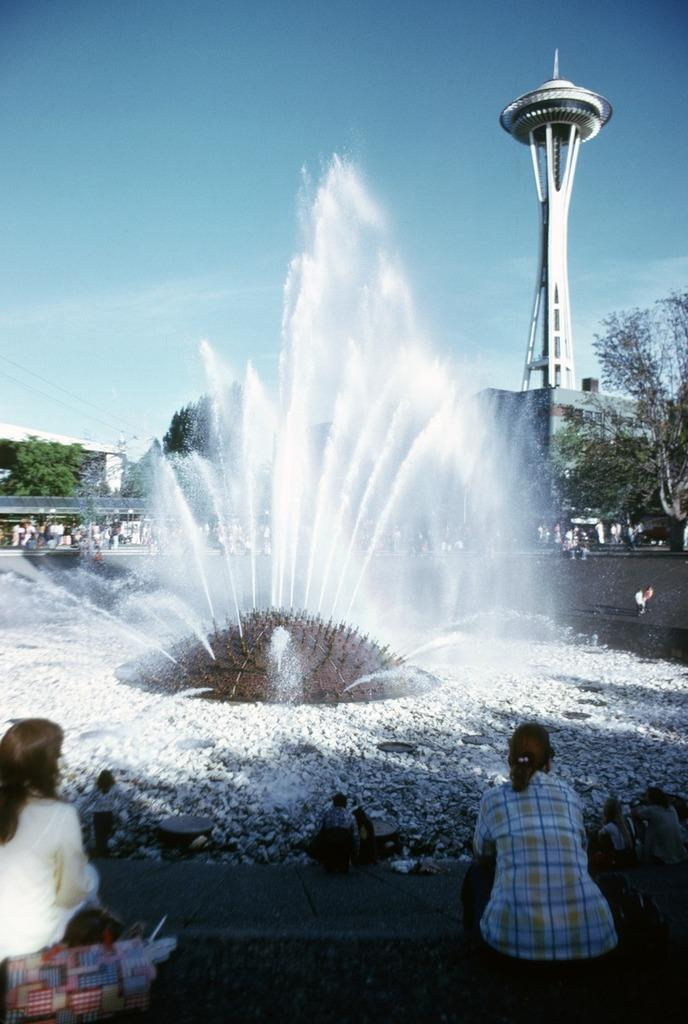Who or what is present in the image? There are people in the image. What type of natural elements can be seen in the image? There are stones, trees, and clouds in the image. What type of man-made structures are visible in the image? There are buildings and a tower in the image. Is there any water feature in the image? Yes, there is a fountain in the image. What design is used for the bath in the image? There is no bath present in the image. What type of shock can be seen on the people's faces in the image? There is no indication of shock on the people's faces in the image. 